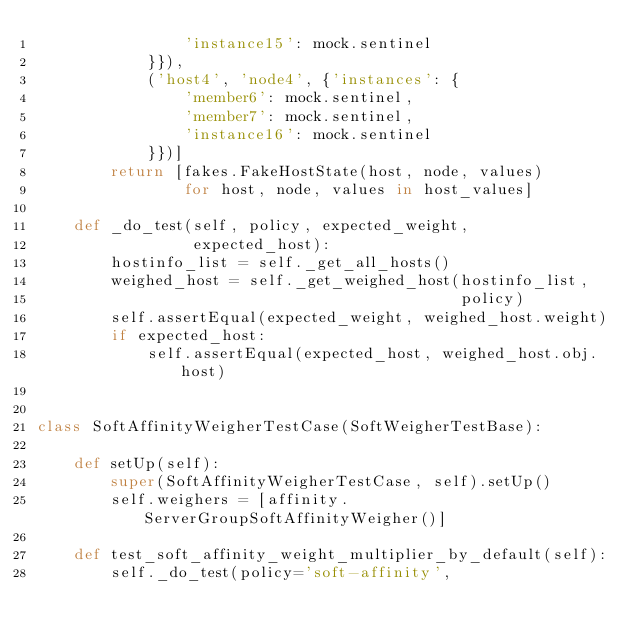Convert code to text. <code><loc_0><loc_0><loc_500><loc_500><_Python_>                'instance15': mock.sentinel
            }}),
            ('host4', 'node4', {'instances': {
                'member6': mock.sentinel,
                'member7': mock.sentinel,
                'instance16': mock.sentinel
            }})]
        return [fakes.FakeHostState(host, node, values)
                for host, node, values in host_values]

    def _do_test(self, policy, expected_weight,
                 expected_host):
        hostinfo_list = self._get_all_hosts()
        weighed_host = self._get_weighed_host(hostinfo_list,
                                              policy)
        self.assertEqual(expected_weight, weighed_host.weight)
        if expected_host:
            self.assertEqual(expected_host, weighed_host.obj.host)


class SoftAffinityWeigherTestCase(SoftWeigherTestBase):

    def setUp(self):
        super(SoftAffinityWeigherTestCase, self).setUp()
        self.weighers = [affinity.ServerGroupSoftAffinityWeigher()]

    def test_soft_affinity_weight_multiplier_by_default(self):
        self._do_test(policy='soft-affinity',</code> 